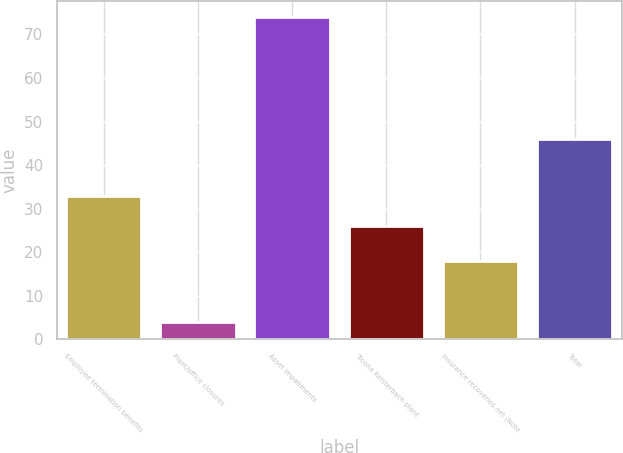<chart> <loc_0><loc_0><loc_500><loc_500><bar_chart><fcel>Employee termination benefits<fcel>Plant/office closures<fcel>Asset impairments<fcel>Ticona Kelsterbach plant<fcel>Insurance recoveries net (Note<fcel>Total<nl><fcel>33<fcel>4<fcel>74<fcel>26<fcel>18<fcel>46<nl></chart> 